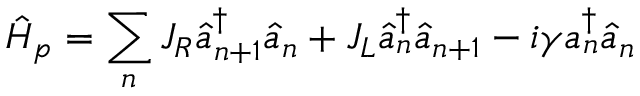Convert formula to latex. <formula><loc_0><loc_0><loc_500><loc_500>\hat { H } _ { p } = \sum _ { n } J _ { R } \hat { a } _ { n + 1 } ^ { \dagger } \hat { a } _ { n } + J _ { L } \hat { a } _ { n } ^ { \dagger } \hat { a } _ { n + 1 } - i \gamma a _ { n } ^ { \dagger } \hat { a } _ { n } \,</formula> 